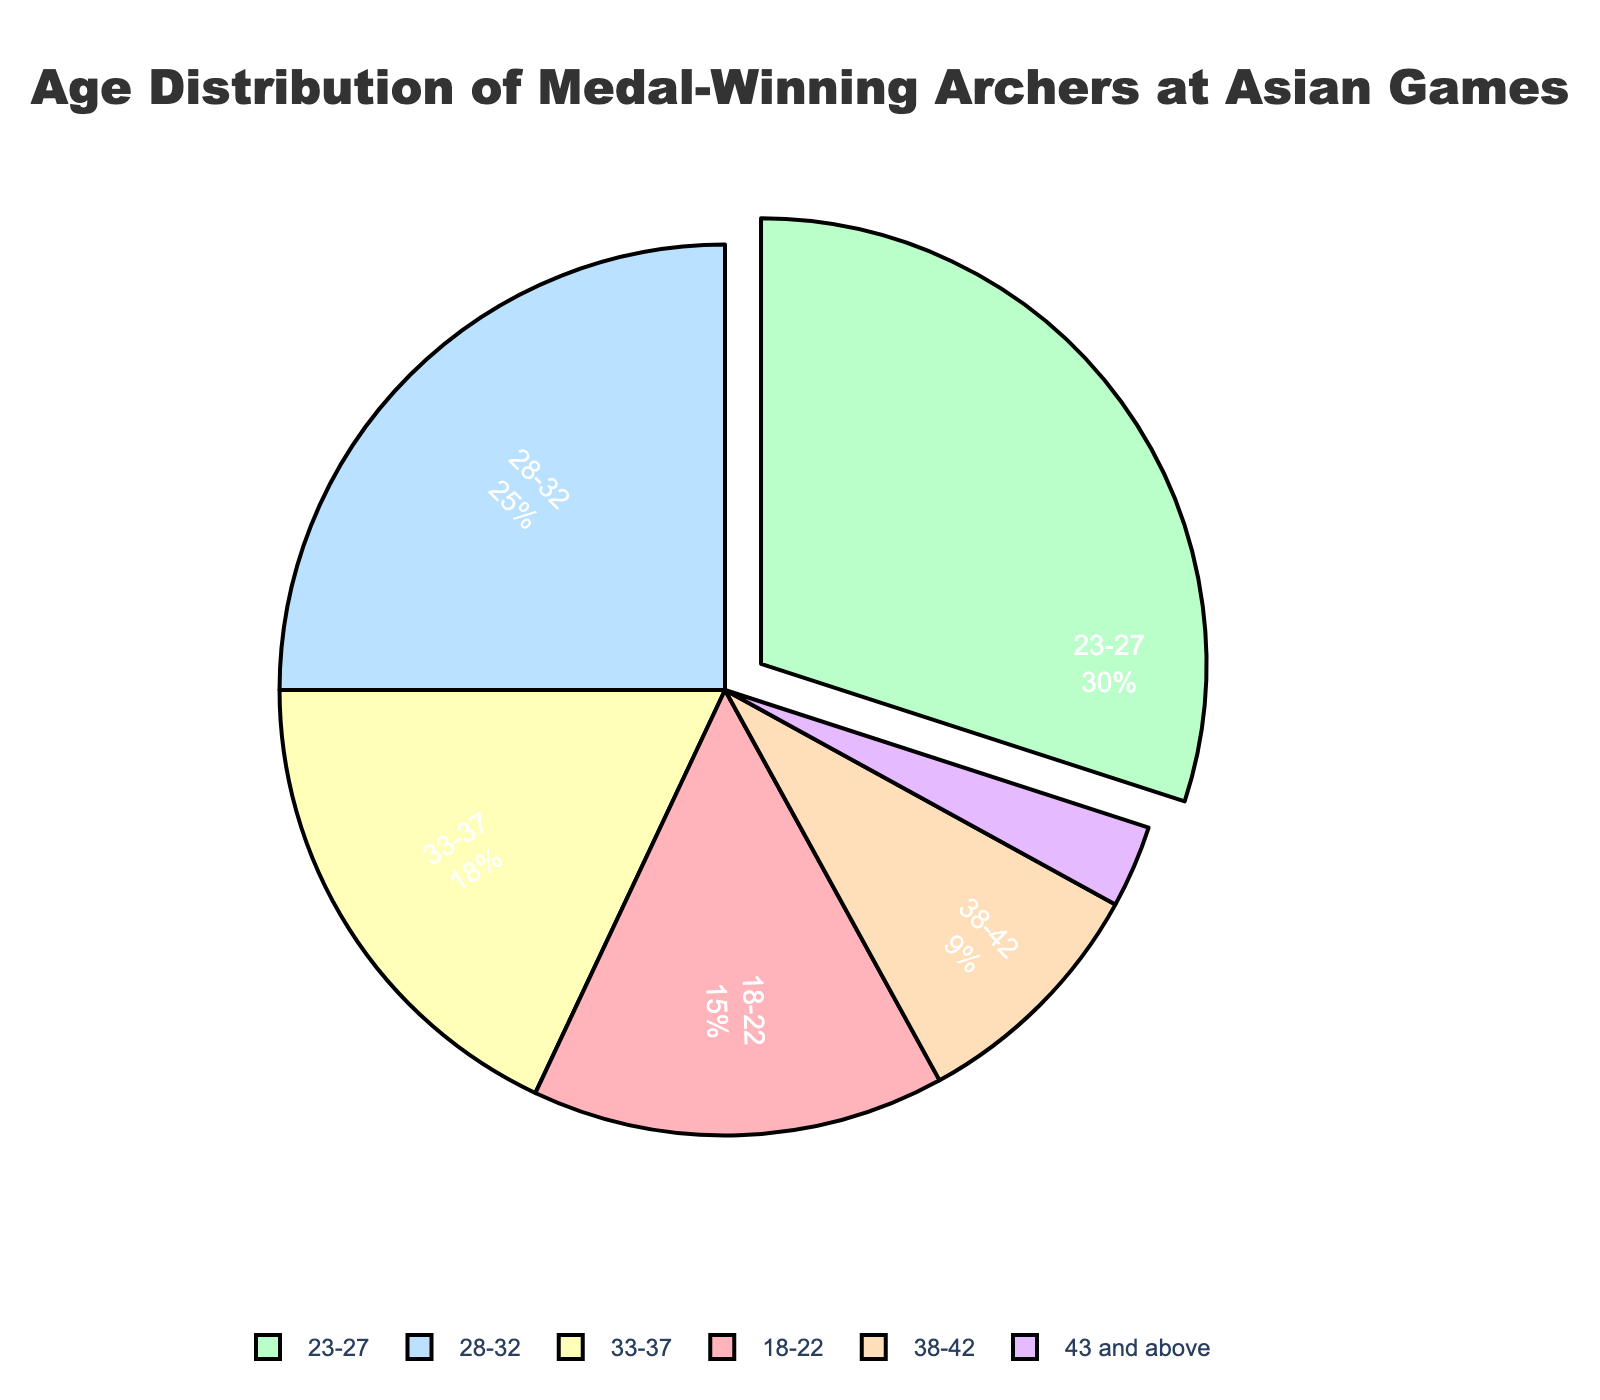What age group has the highest percentage of medal-winning archers? The pie chart shows different age groups along with their percentages. We can see that the 23-27 age group has the largest section. Therefore, the 23-27 age group has the highest percentage.
Answer: 23-27 What is the total percentage represented by archers aged 28-32 and 33-37? We need to add the percentages of the 28-32 age group and the 33-37 age group. According to the chart, these percentages are 25 and 18, respectively. So, 25 + 18 = 43%.
Answer: 43% Which age group is represented by the smallest percentage of medal-winning archers? The pie chart indicates the percentages for different age groups. The 43 and above age group has the smallest section with 3%. Therefore, this is the smallest percentage.
Answer: 43 and above By how much does the percentage of archers aged 23-27 exceed those aged 18-22? We need to subtract the percentage of the 18-22 age group from the 23-27 age group. The chart shows these percentages are 30 and 15, respectively. So, 30 - 15 = 15%.
Answer: 15% What is the combined percentage of archers aged under 23 and those aged over 37? We need to add the percentages of the 18-22 age group, the 38-42 age group, and the 43 and above age group. The chart shows these are 15%, 9%, and 3%, respectively. So, 15 + 9 + 3 = 27%.
Answer: 27% What percentage of medal-winning archers are aged between 28 and 42? We need to add the percentages of the 28-32 and the 33-37 age groups as well as the 38-42 age group. According to the pie chart, these percentages are 25%, 18%, and 9%, respectively. So, 25 + 18 + 9 = 52%.
Answer: 52% Which age group stands out visually due to being pulled out from the pie chart? The visual indicates that one section of the pie chart is pulled out more prominently compared to others. The biggest slice representing the 23-27 age group is visually distinguished in this way.
Answer: 23-27 How does the percentage of archers in the 33-37 age group compare to the 28-32 age group? We observe the values from the pie chart. The 33-37 group has 18%, and the 28-32 group has 25%. Therefore, the 33-37 group's percentage is less than the 28-32 group's percentage.
Answer: less than 